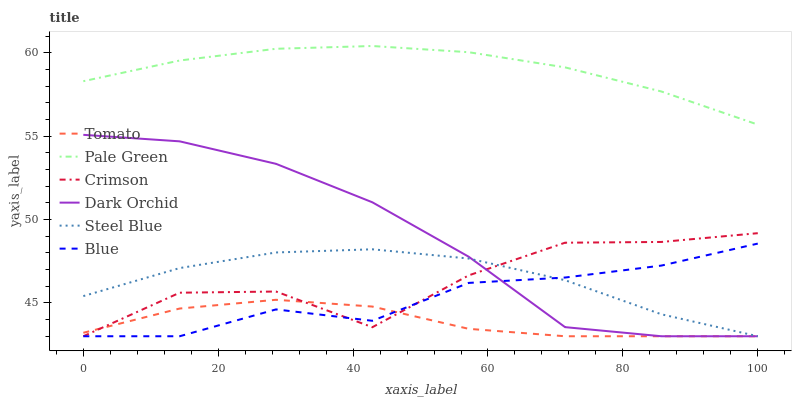Does Blue have the minimum area under the curve?
Answer yes or no. No. Does Blue have the maximum area under the curve?
Answer yes or no. No. Is Blue the smoothest?
Answer yes or no. No. Is Blue the roughest?
Answer yes or no. No. Does Pale Green have the lowest value?
Answer yes or no. No. Does Blue have the highest value?
Answer yes or no. No. Is Steel Blue less than Pale Green?
Answer yes or no. Yes. Is Pale Green greater than Dark Orchid?
Answer yes or no. Yes. Does Steel Blue intersect Pale Green?
Answer yes or no. No. 